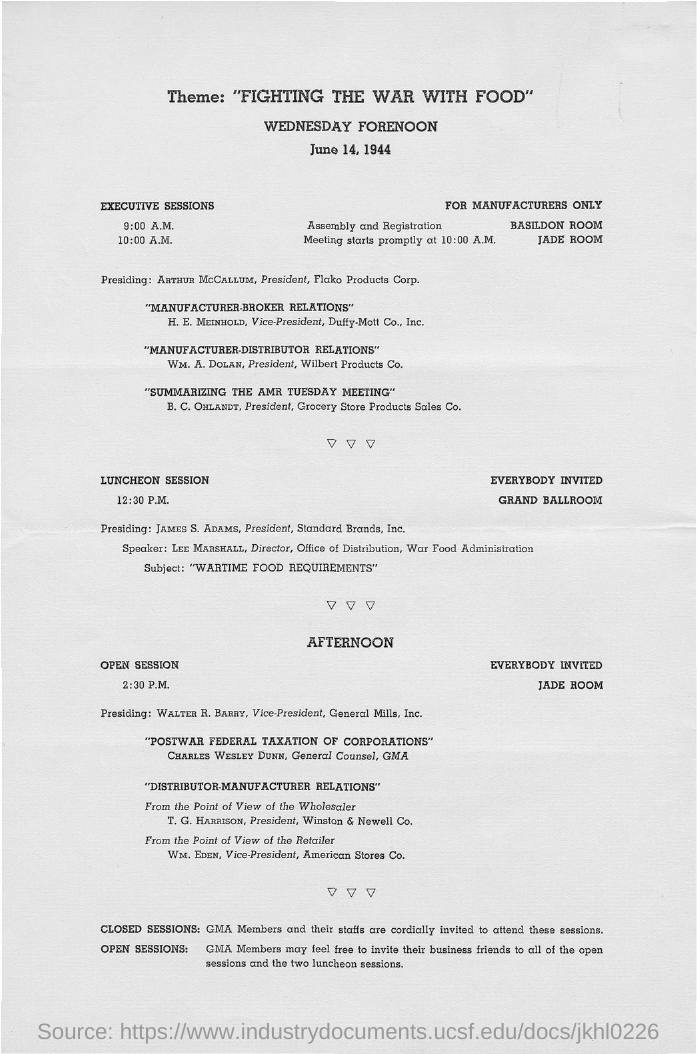Give some essential details in this illustration. William Eden is the vice-president of American Stores Co. Walter R. Barry is the vice-president of General Mills, Inc. William A. Dolan is the president of Wilbert Products Co. The president of Standard Brands, Inc. is James S. Adams. 